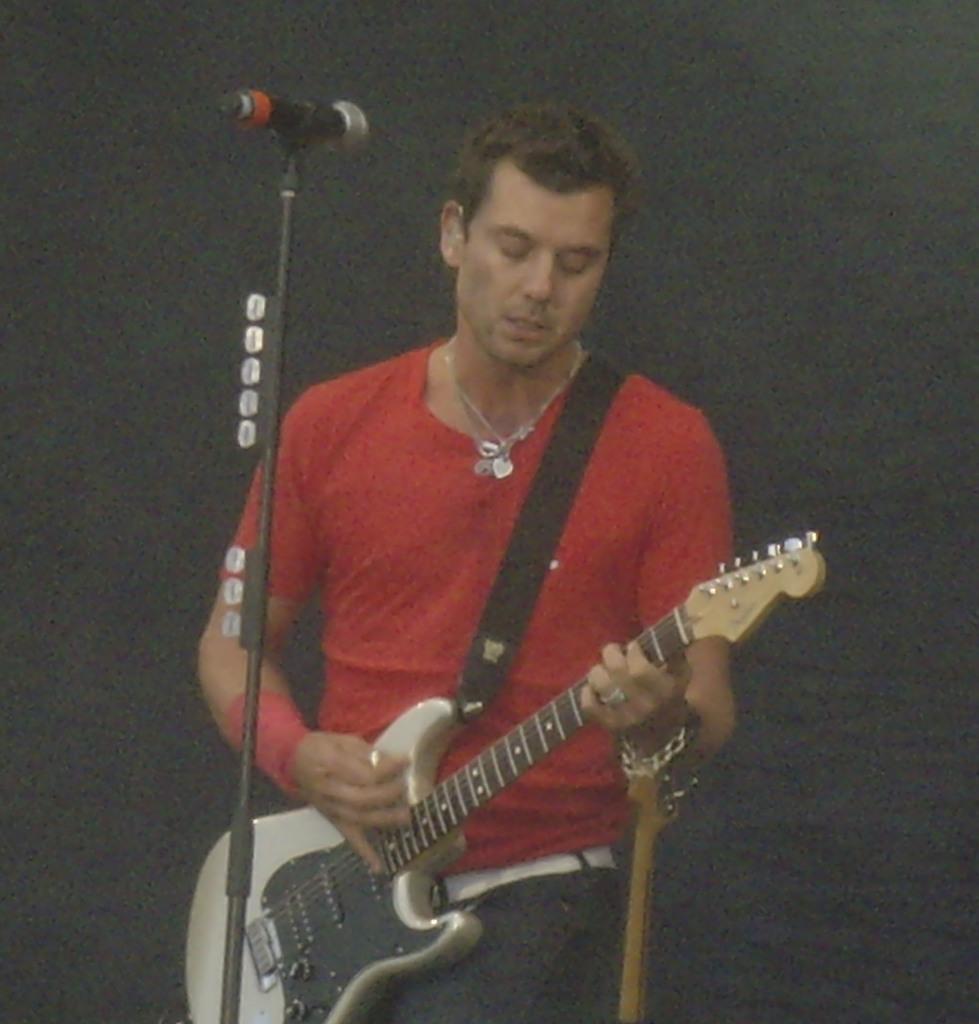Can you describe this image briefly? In this image a man is playing guitar in front of microphone. 